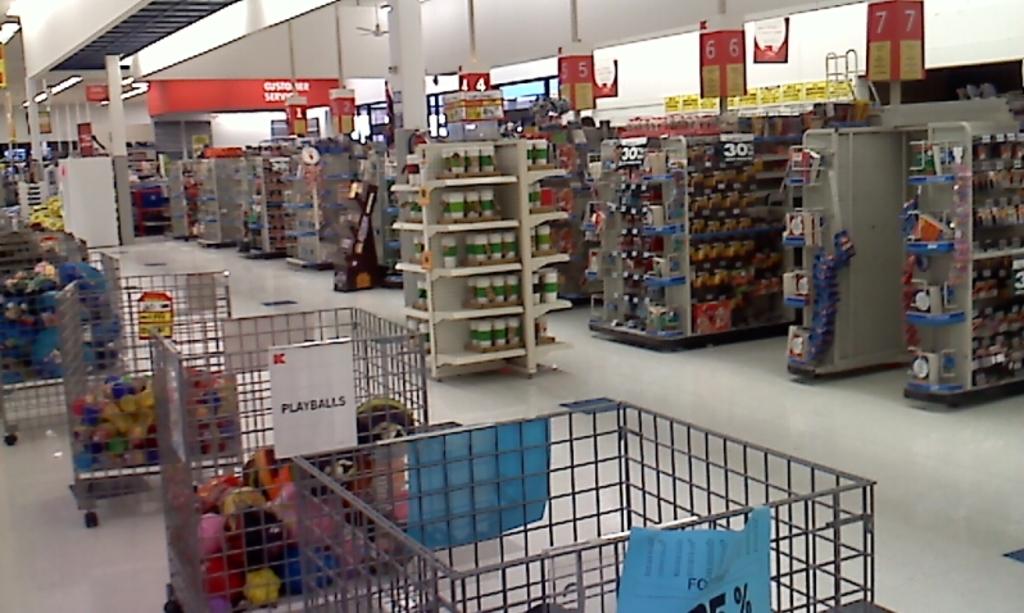Which number is the cashier closet to the camera?
Provide a succinct answer. 7. 